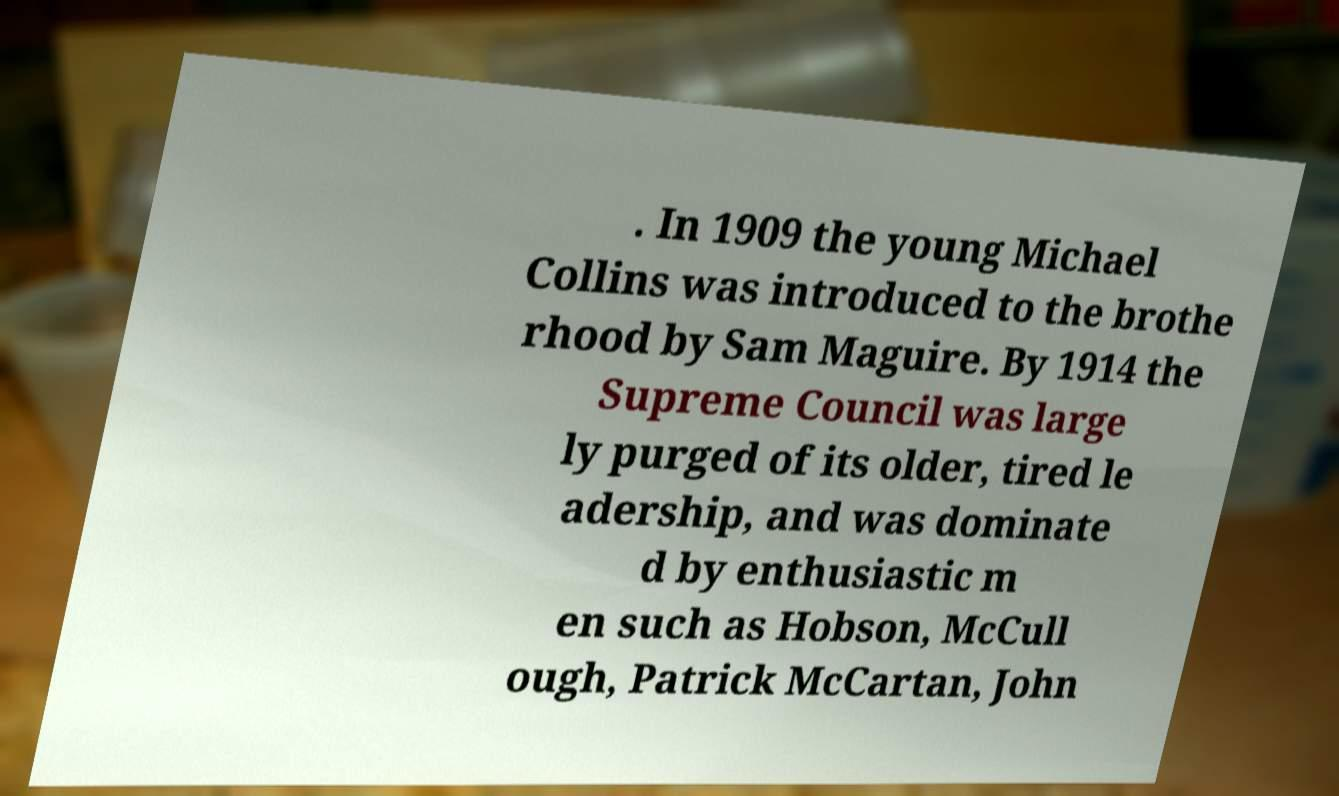Can you accurately transcribe the text from the provided image for me? . In 1909 the young Michael Collins was introduced to the brothe rhood by Sam Maguire. By 1914 the Supreme Council was large ly purged of its older, tired le adership, and was dominate d by enthusiastic m en such as Hobson, McCull ough, Patrick McCartan, John 